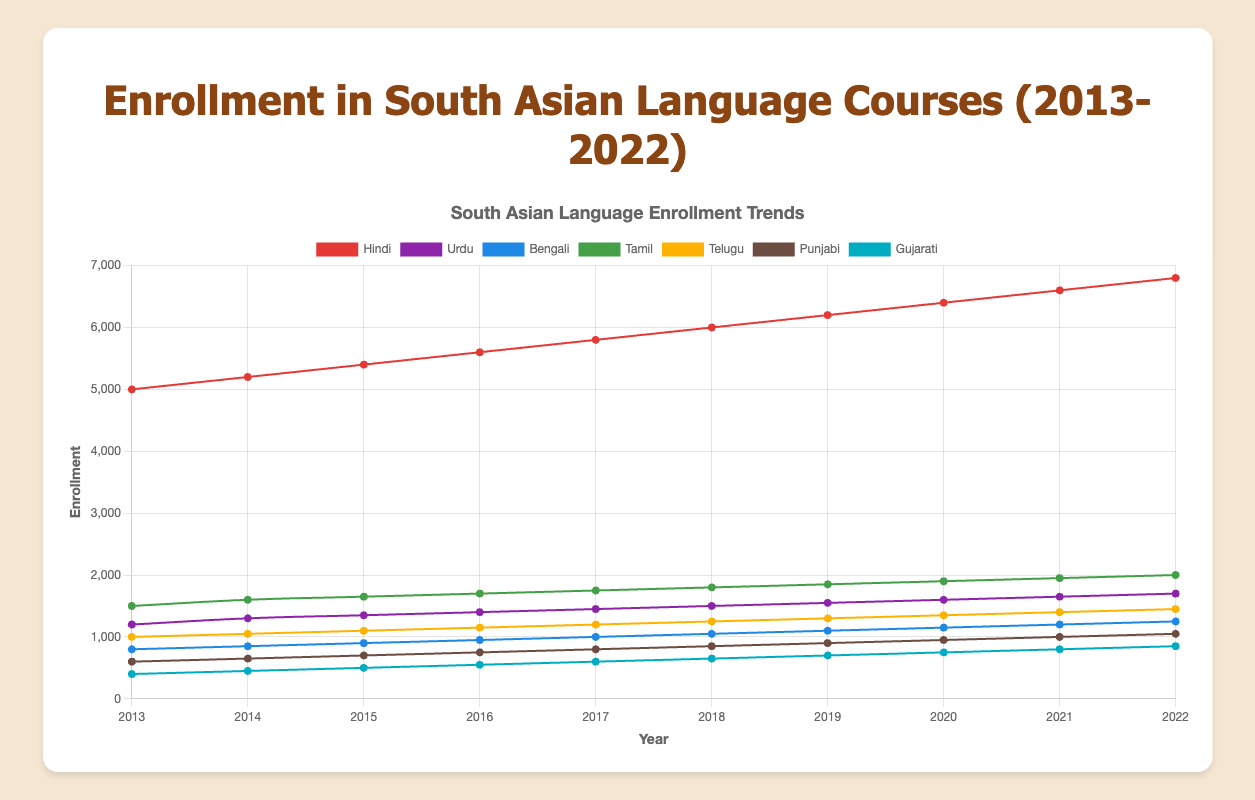Which South Asian language had the highest enrollment in 2022? The highest point on the y-axis in 2022 corresponds to Hindi.
Answer: Hindi What was the total combined enrollment for all languages in 2015? In 2015, add the enrollments for each language Hindi (5400) + Urdu (1350) + Bengali (900) + Tamil (1650) + Telugu (1100) + Punjabi (700) + Gujarati (500) = 12200.
Answer: 12200 Did the enrollment for Bengali increase, decrease, or stay the same between 2013 and 2022? Comparing the enrollment figures for Bengali in 2013 (800) and 2022 (1250), there is an increase.
Answer: Increase Which language had the smallest rate of increase in enrollment from 2013 to 2022? Calculate the difference in enrollment for each language between 2013 and 2022, find the smallest rate: Punjabi (1050-600)=450, thus, Punjabi has the smallest increase.
Answer: Punjabi What was the average enrollment for Tamil courses over the decade? Add all the annual enrollments for Tamil and divide by the number of years: (1500 + 1600 + 1650 + 1700 + 1750 + 1800 + 1850 + 1900 + 1950 + 2000)/10 = 1770.
Answer: 1770 By how much did the enrollment for Telugu increase from 2018 to 2022? Calculate the difference between enrollments for Telugu in 2022 (1450) and 2018 (1250): 1450 - 1250 = 200.
Answer: 200 Which two languages had the closest enrollment numbers in 2020? Comparing the enrollment numbers for 2020, Urdu (1600) and Bengali (1150) have a difference of 450, closer than other pairs based on visual inspection.
Answer: Urdu and Bengali Was there any year where enrollment in Tamil surpassed 1900? If so, which year? In the graph, for Tamil, the enrollment surpasses 1900 in 2021 (1950) and 2022 (2000).
Answer: 2021 and 2022 How did Hindi and Telugu enrollments compare in 2016? In 2016, Hindi (5600) and Telugu (1150) show that Hindi had a significantly higher enrollment.
Answer: Hindi higher than Telugu What color represents the Gujarati enrollment trend in the chart? Observing the graph, the trend line for Gujarati is colored in a specific color, which is light blue.
Answer: Blue 